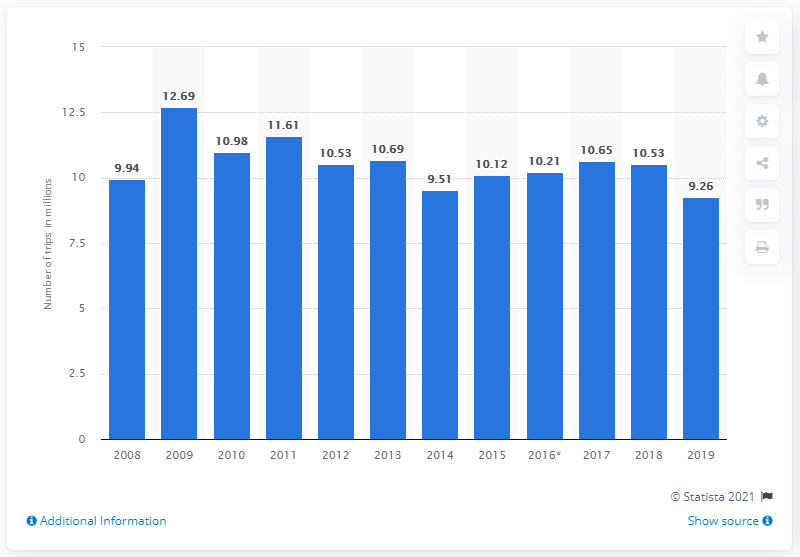Mention a couple of crucial points in this snapshot. In England, between 2008 and 2019, a total of 9.26 million camping and caravanning holidays were taken by domestic tourists. 